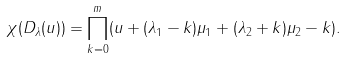Convert formula to latex. <formula><loc_0><loc_0><loc_500><loc_500>\chi ( D _ { \lambda } ( u ) ) = \prod _ { k = 0 } ^ { m } ( u + ( \lambda _ { 1 } - k ) \mu _ { 1 } + ( \lambda _ { 2 } + k ) \mu _ { 2 } - k ) .</formula> 